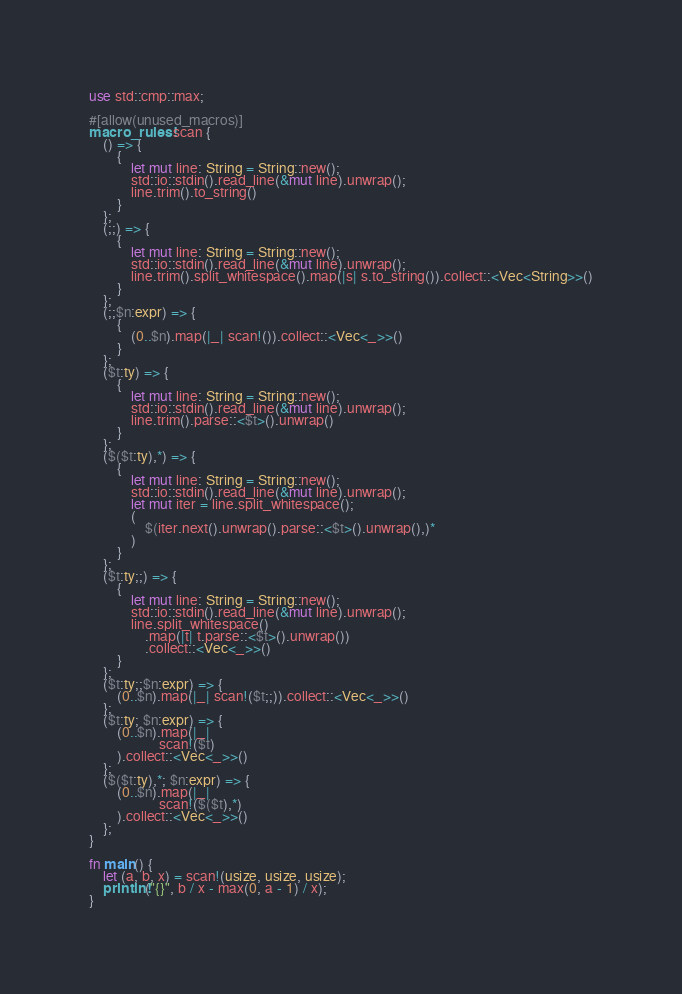<code> <loc_0><loc_0><loc_500><loc_500><_Rust_>use std::cmp::max;

#[allow(unused_macros)]
macro_rules! scan {
    () => {
        {
            let mut line: String = String::new();
            std::io::stdin().read_line(&mut line).unwrap();
            line.trim().to_string()
        }
    };
    (;;) => {
        {
            let mut line: String = String::new();
            std::io::stdin().read_line(&mut line).unwrap();
            line.trim().split_whitespace().map(|s| s.to_string()).collect::<Vec<String>>()
        }
    };
    (;;$n:expr) => {
        {
            (0..$n).map(|_| scan!()).collect::<Vec<_>>()
        }
    };
    ($t:ty) => {
        {
            let mut line: String = String::new();
            std::io::stdin().read_line(&mut line).unwrap();
            line.trim().parse::<$t>().unwrap()
        }
    };
    ($($t:ty),*) => {
        {
            let mut line: String = String::new();
            std::io::stdin().read_line(&mut line).unwrap();
            let mut iter = line.split_whitespace();
            (
                $(iter.next().unwrap().parse::<$t>().unwrap(),)*
            )
        }
    };
    ($t:ty;;) => {
        {
            let mut line: String = String::new();
            std::io::stdin().read_line(&mut line).unwrap();
            line.split_whitespace()
                .map(|t| t.parse::<$t>().unwrap())
                .collect::<Vec<_>>()
        }
    };
    ($t:ty;;$n:expr) => {
        (0..$n).map(|_| scan!($t;;)).collect::<Vec<_>>()
    };
    ($t:ty; $n:expr) => {
        (0..$n).map(|_|
                    scan!($t)
        ).collect::<Vec<_>>()
    };
    ($($t:ty),*; $n:expr) => {
        (0..$n).map(|_|
                    scan!($($t),*)
        ).collect::<Vec<_>>()
    };
}

fn main() {
    let (a, b, x) = scan!(usize, usize, usize);
    println!("{}", b / x - max(0, a - 1) / x);
}
</code> 